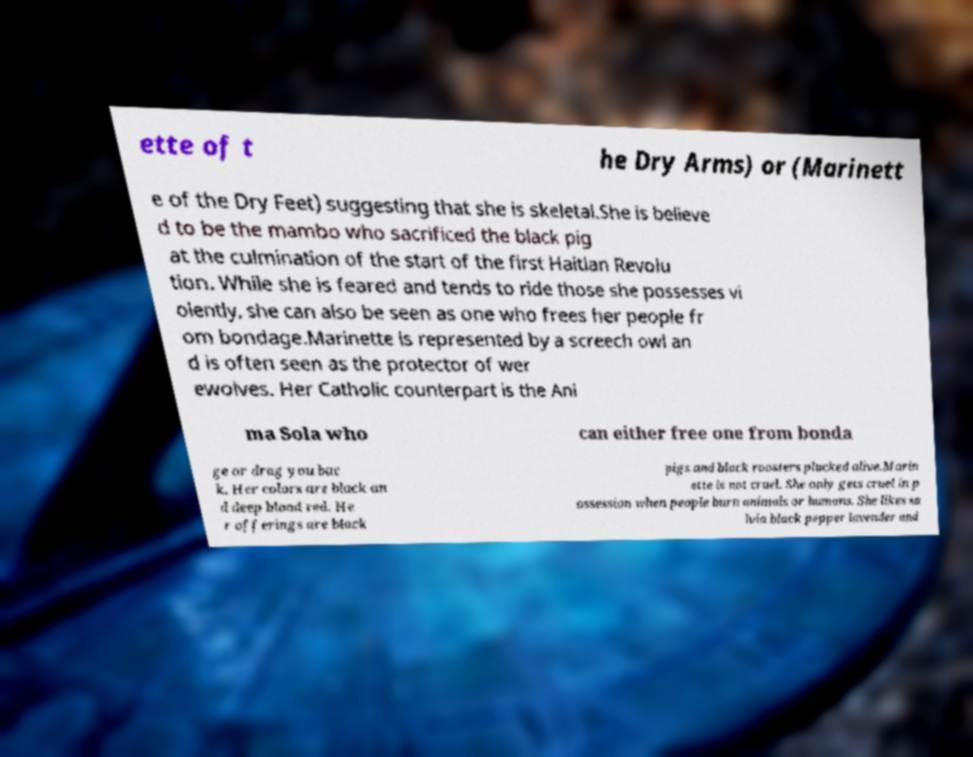Can you read and provide the text displayed in the image?This photo seems to have some interesting text. Can you extract and type it out for me? ette of t he Dry Arms) or (Marinett e of the Dry Feet) suggesting that she is skeletal.She is believe d to be the mambo who sacrificed the black pig at the culmination of the start of the first Haitian Revolu tion. While she is feared and tends to ride those she possesses vi olently, she can also be seen as one who frees her people fr om bondage.Marinette is represented by a screech owl an d is often seen as the protector of wer ewolves. Her Catholic counterpart is the Ani ma Sola who can either free one from bonda ge or drag you bac k. Her colors are black an d deep blood red. He r offerings are black pigs and black roosters plucked alive.Marin ette is not cruel. She only gets cruel in p ossession when people burn animals or humans. She likes sa lvia black pepper lavender and 